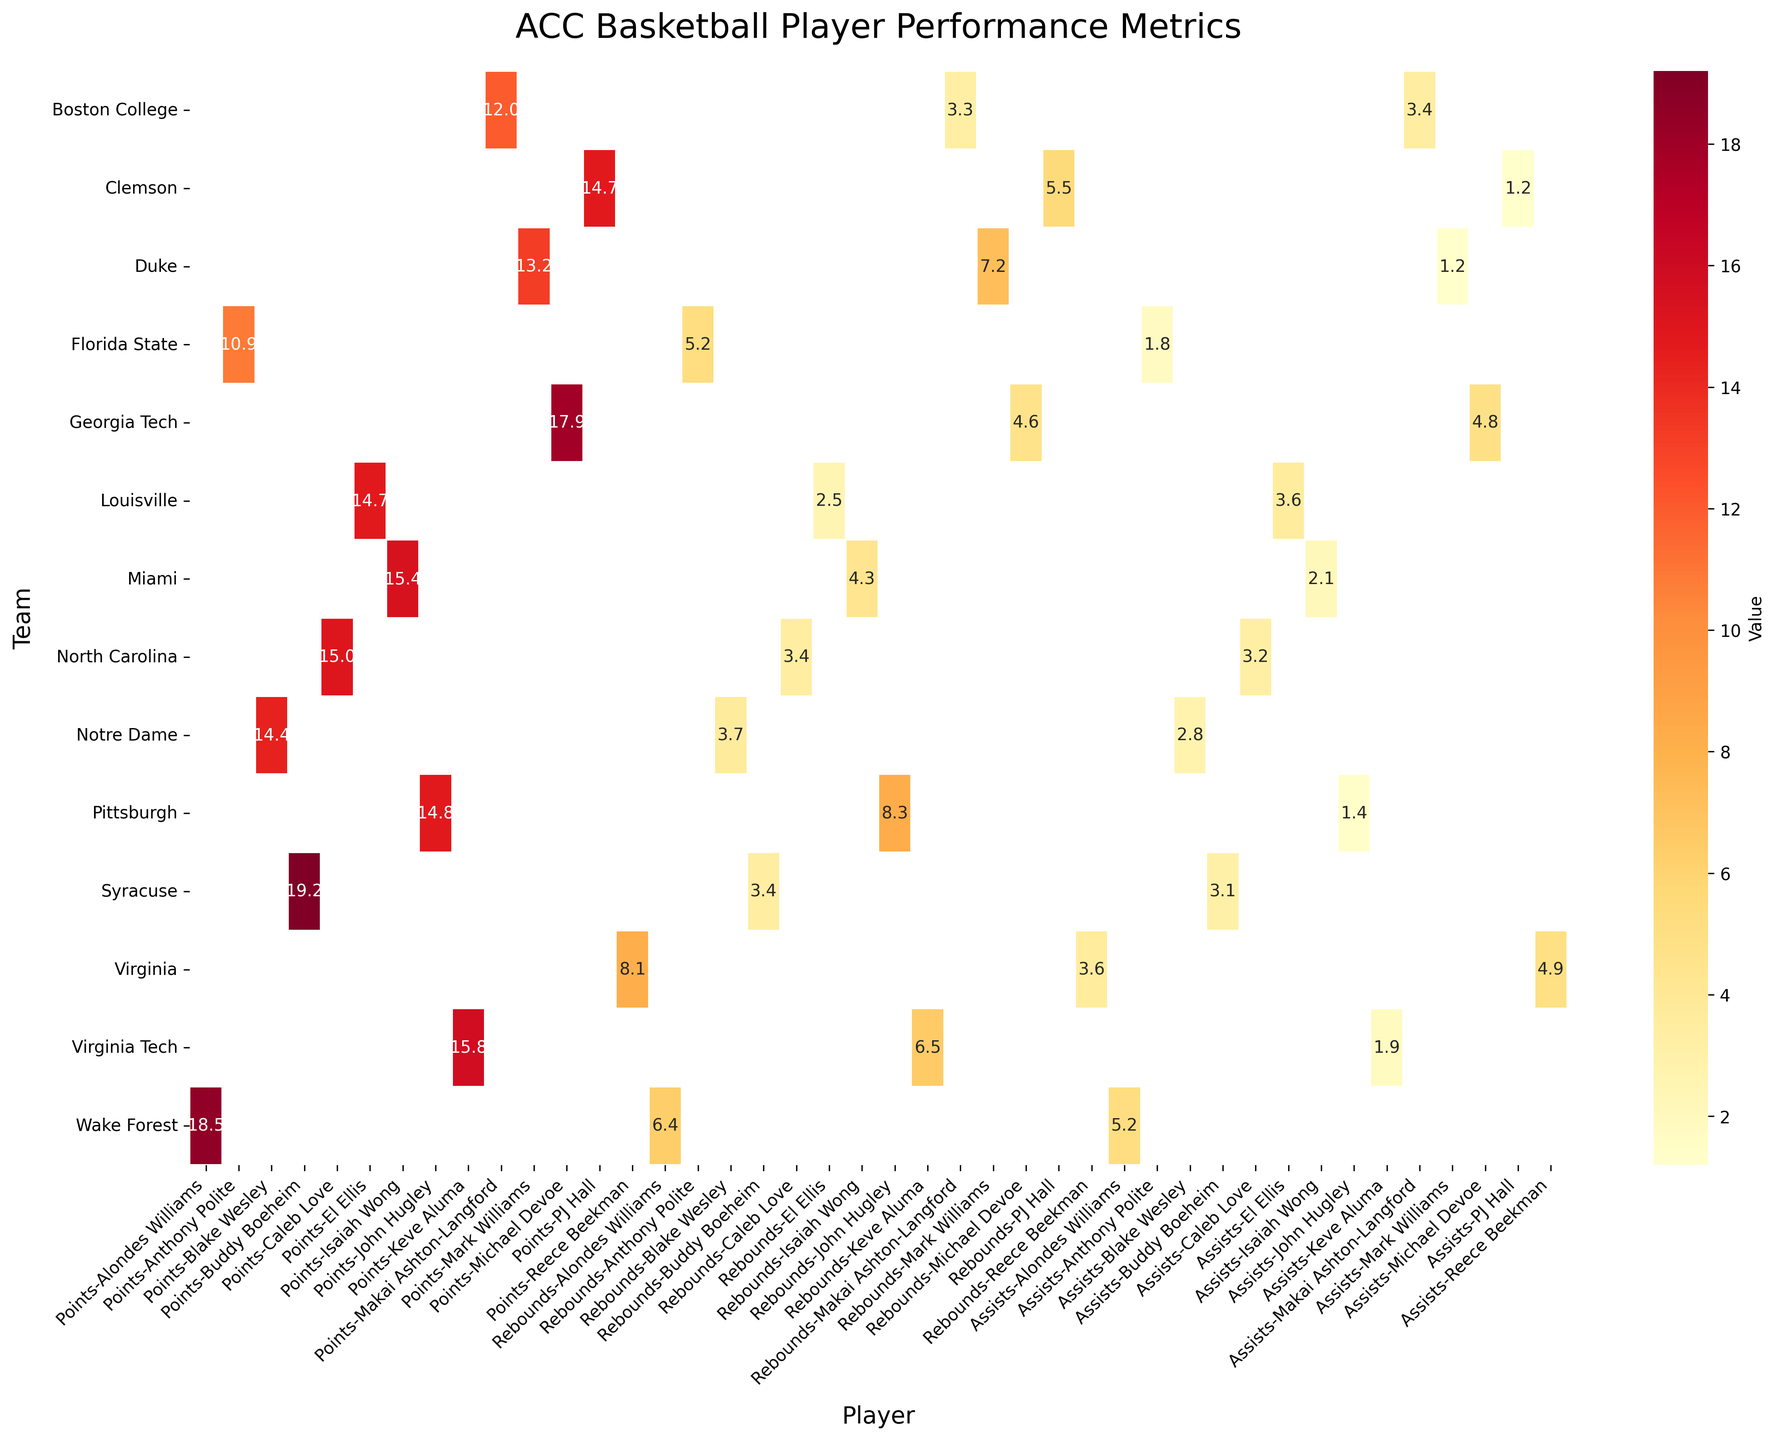What's the average points scored by players from Miami and Virginia Tech? First, find the points for Miami's Isaiah Wong (15.4) and Virginia Tech's Keve Aluma (15.8). Then compute the average: (15.4 + 15.8) / 2 = 15.6
Answer: 15.6 Which player has the highest number of rebounds? Compare the rebound values for all players. John Hugley of Pittsburgh has the highest rebounds with 8.3.
Answer: John Hugley Is the average assists for players from Duke and Syracuse greater than 2.5? Find the assists for Mark Williams (Duke) which is 1.2 and Buddy Boeheim (Syracuse) which is 3.1. Compute the average: (1.2 + 3.1) / 2 = 2.15. Compare with 2.5, and find it's less.
Answer: No What is the difference in points between the highest and lowest-scoring players? Identify the highest points (Buddy Boeheim with 19.2) and the lowest points (Reece Beekman with 8.1). Calculate the difference: 19.2 - 8.1 = 11.1
Answer: 11.1 Which team has the player with the highest assists? Compare the assists values for all players. Alondes Williams from Wake Forest has the highest assists with 5.2.
Answer: Wake Forest How many players have more than 5 rebounds? Count the players with rebound values greater than 5. They are Mark Williams (Duke), PJ Hall (Clemson), Keve Aluma (Virginia Tech), and John Hugley (Pittsburgh), making a total of 4.
Answer: 4 Which player from the provided teams has the lowest points but the highest assists? Evaluate the lowest points: Reece Beekman (Virginia) with 8.1. Check Reece Beekman's assists, which is 4.9. However, Alondes Williams (Wake Forest) has 5.2 assists, thus the lowest points with highest assists is not applicable for highest assists. Reece Beekman has the highest assists among those with lowest points.
Answer: Reece Beekman What is the total number of assists by players from North Carolina and Louisville combined? Sum the assists values for Caleb Love (North Carolina) and El Ellis (Louisville): 3.2 + 3.6 = 6.8
Answer: 6.8 